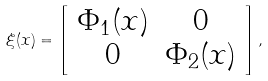Convert formula to latex. <formula><loc_0><loc_0><loc_500><loc_500>\xi ( x ) = \left [ \begin{array} { c c c } \Phi _ { 1 } ( x ) & 0 \\ 0 & \Phi _ { 2 } ( x ) \\ \end{array} \right ] ,</formula> 